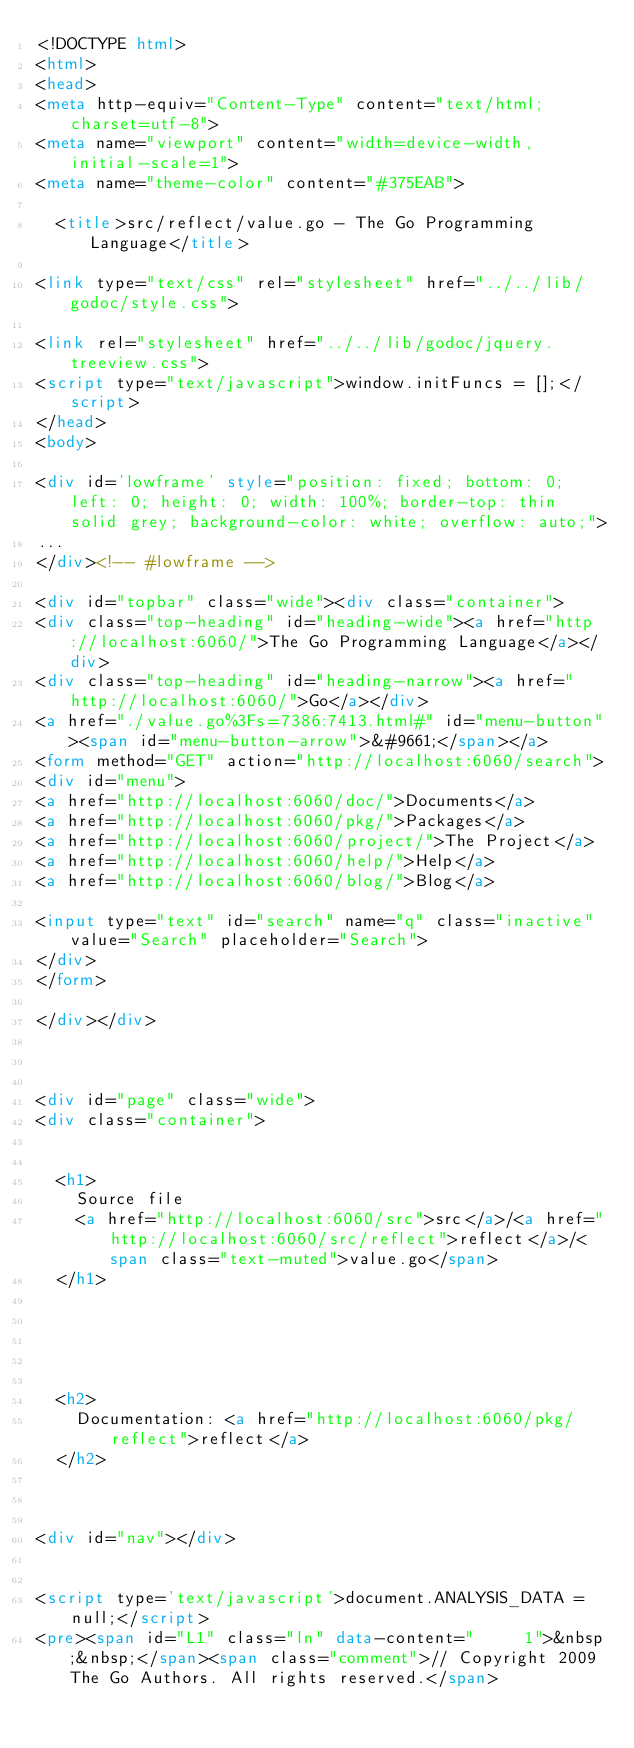<code> <loc_0><loc_0><loc_500><loc_500><_HTML_><!DOCTYPE html>
<html>
<head>
<meta http-equiv="Content-Type" content="text/html; charset=utf-8">
<meta name="viewport" content="width=device-width, initial-scale=1">
<meta name="theme-color" content="#375EAB">

  <title>src/reflect/value.go - The Go Programming Language</title>

<link type="text/css" rel="stylesheet" href="../../lib/godoc/style.css">

<link rel="stylesheet" href="../../lib/godoc/jquery.treeview.css">
<script type="text/javascript">window.initFuncs = [];</script>
</head>
<body>

<div id='lowframe' style="position: fixed; bottom: 0; left: 0; height: 0; width: 100%; border-top: thin solid grey; background-color: white; overflow: auto;">
...
</div><!-- #lowframe -->

<div id="topbar" class="wide"><div class="container">
<div class="top-heading" id="heading-wide"><a href="http://localhost:6060/">The Go Programming Language</a></div>
<div class="top-heading" id="heading-narrow"><a href="http://localhost:6060/">Go</a></div>
<a href="./value.go%3Fs=7386:7413.html#" id="menu-button"><span id="menu-button-arrow">&#9661;</span></a>
<form method="GET" action="http://localhost:6060/search">
<div id="menu">
<a href="http://localhost:6060/doc/">Documents</a>
<a href="http://localhost:6060/pkg/">Packages</a>
<a href="http://localhost:6060/project/">The Project</a>
<a href="http://localhost:6060/help/">Help</a>
<a href="http://localhost:6060/blog/">Blog</a>

<input type="text" id="search" name="q" class="inactive" value="Search" placeholder="Search">
</div>
</form>

</div></div>



<div id="page" class="wide">
<div class="container">


  <h1>
    Source file
    <a href="http://localhost:6060/src">src</a>/<a href="http://localhost:6060/src/reflect">reflect</a>/<span class="text-muted">value.go</span>
  </h1>





  <h2>
    Documentation: <a href="http://localhost:6060/pkg/reflect">reflect</a>
  </h2>



<div id="nav"></div>


<script type='text/javascript'>document.ANALYSIS_DATA = null;</script>
<pre><span id="L1" class="ln" data-content="     1">&nbsp;&nbsp;</span><span class="comment">// Copyright 2009 The Go Authors. All rights reserved.</span></code> 